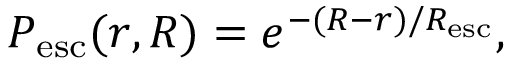Convert formula to latex. <formula><loc_0><loc_0><loc_500><loc_500>P _ { e s c } ( r , R ) = e ^ { - ( R - r ) / R _ { e s c } } ,</formula> 